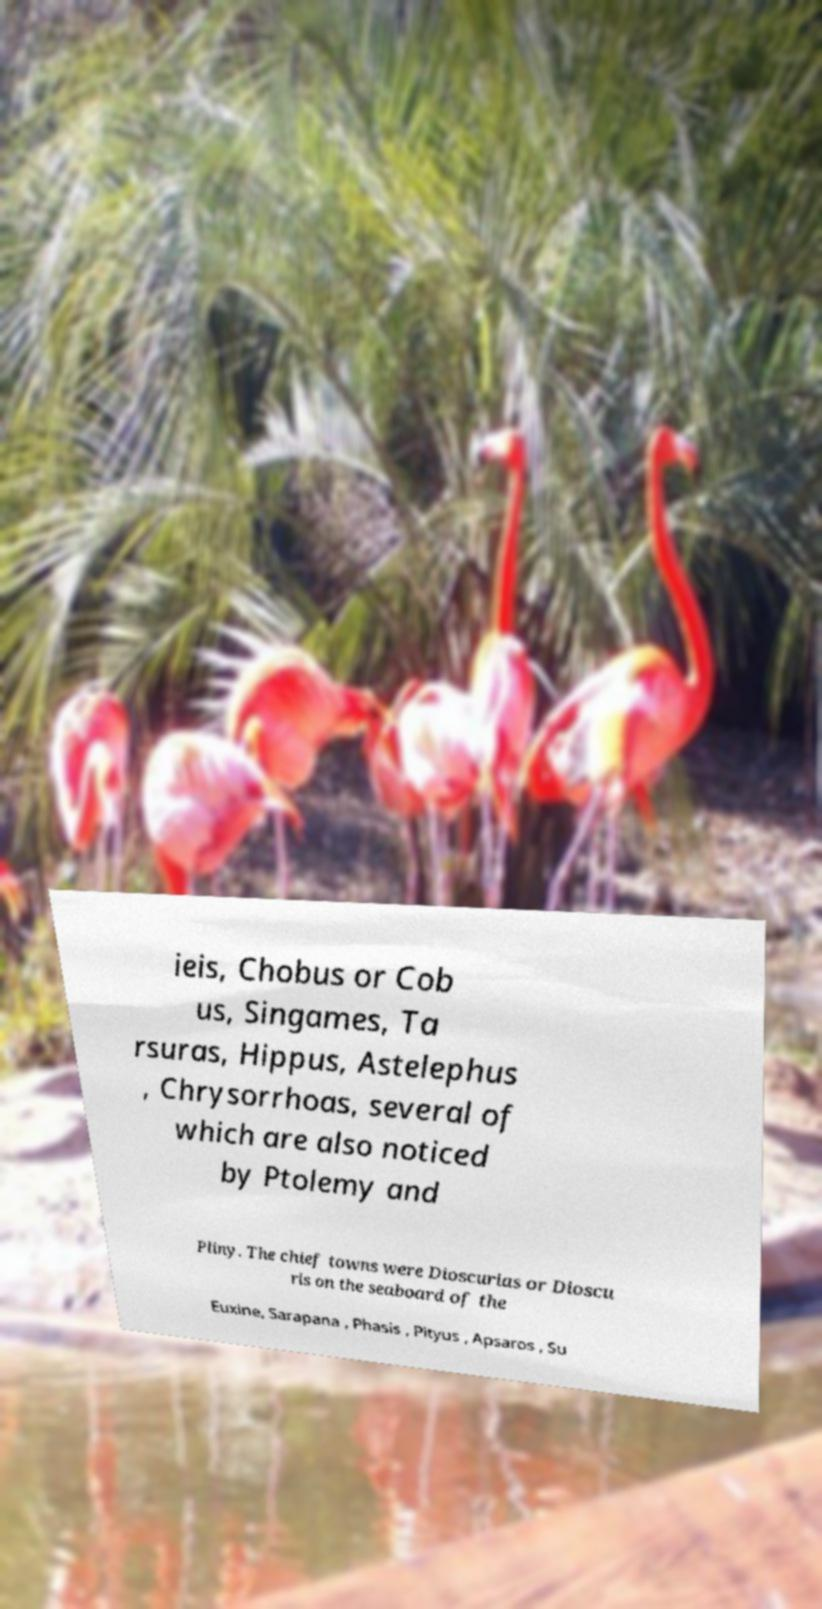What messages or text are displayed in this image? I need them in a readable, typed format. ieis, Chobus or Cob us, Singames, Ta rsuras, Hippus, Astelephus , Chrysorrhoas, several of which are also noticed by Ptolemy and Pliny. The chief towns were Dioscurias or Dioscu ris on the seaboard of the Euxine, Sarapana , Phasis , Pityus , Apsaros , Su 